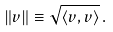<formula> <loc_0><loc_0><loc_500><loc_500>\| v \| \equiv \sqrt { \langle v , v \rangle } \, .</formula> 